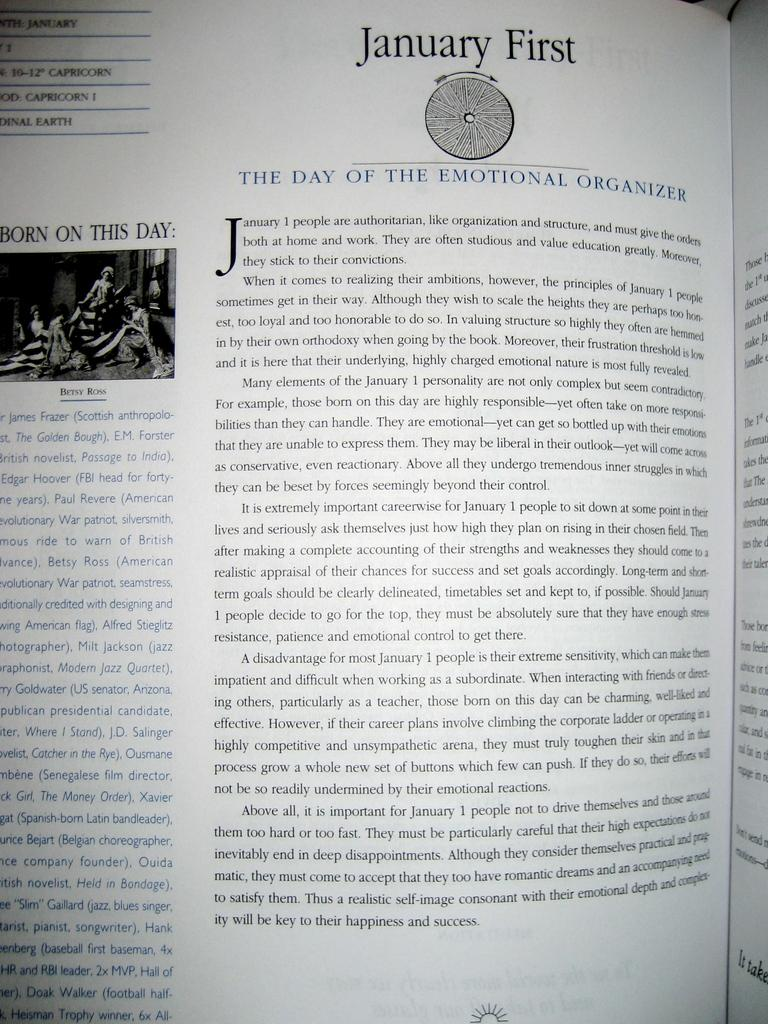<image>
Provide a brief description of the given image. Opened page from a book named "January First" 